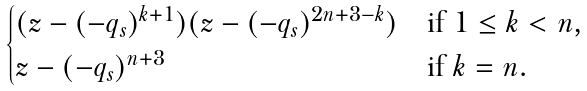<formula> <loc_0><loc_0><loc_500><loc_500>\begin{cases} ( z - ( - q _ { s } ) ^ { k + 1 } ) ( z - ( - q _ { s } ) ^ { 2 n + 3 - k } ) & \text {if $1\leq k<n$,} \\ z - ( - q _ { s } ) ^ { n + 3 } & \text {if $k=n$.} \end{cases}</formula> 